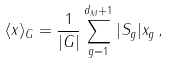<formula> <loc_0><loc_0><loc_500><loc_500>\langle x \rangle _ { G } = \frac { 1 } { | G | } \sum _ { g = 1 } ^ { d _ { M } + 1 } | S _ { g } | x _ { g } \, ,</formula> 